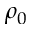Convert formula to latex. <formula><loc_0><loc_0><loc_500><loc_500>\rho _ { 0 }</formula> 